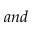Convert formula to latex. <formula><loc_0><loc_0><loc_500><loc_500>a n d</formula> 